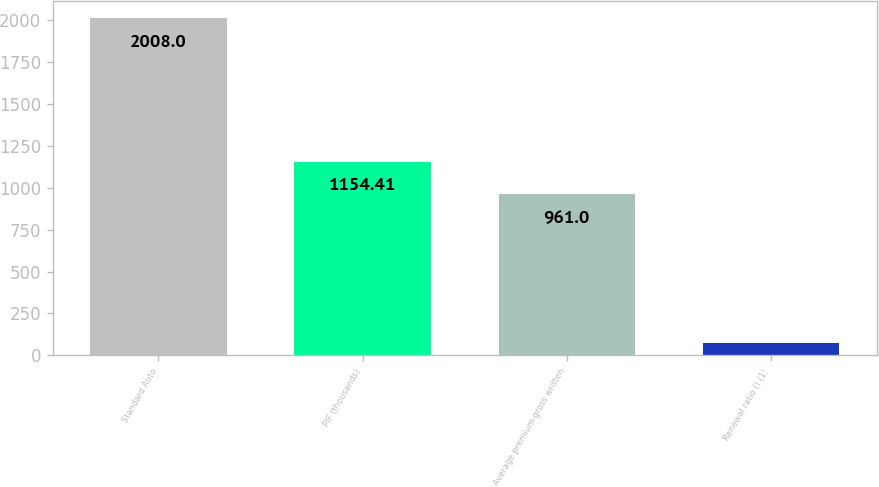<chart> <loc_0><loc_0><loc_500><loc_500><bar_chart><fcel>Standard Auto<fcel>PIF (thousands)<fcel>Average premium-gross written<fcel>Renewal ratio () (1)<nl><fcel>2008<fcel>1154.41<fcel>961<fcel>73.9<nl></chart> 